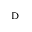Convert formula to latex. <formula><loc_0><loc_0><loc_500><loc_500>_ { D }</formula> 